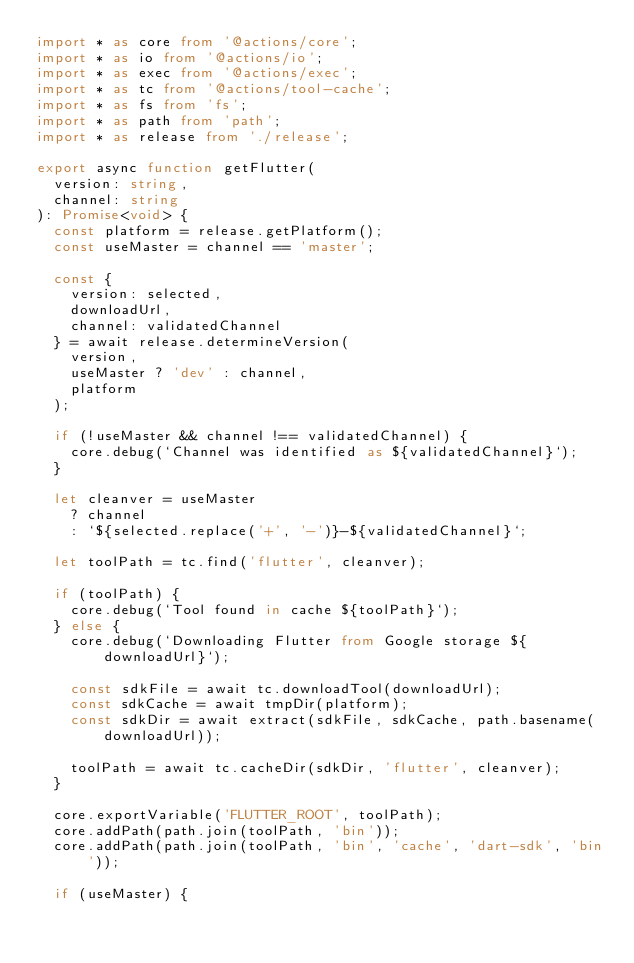Convert code to text. <code><loc_0><loc_0><loc_500><loc_500><_TypeScript_>import * as core from '@actions/core';
import * as io from '@actions/io';
import * as exec from '@actions/exec';
import * as tc from '@actions/tool-cache';
import * as fs from 'fs';
import * as path from 'path';
import * as release from './release';

export async function getFlutter(
  version: string,
  channel: string
): Promise<void> {
  const platform = release.getPlatform();
  const useMaster = channel == 'master';

  const {
    version: selected,
    downloadUrl,
    channel: validatedChannel
  } = await release.determineVersion(
    version,
    useMaster ? 'dev' : channel,
    platform
  );

  if (!useMaster && channel !== validatedChannel) {
    core.debug(`Channel was identified as ${validatedChannel}`);
  }

  let cleanver = useMaster
    ? channel
    : `${selected.replace('+', '-')}-${validatedChannel}`;

  let toolPath = tc.find('flutter', cleanver);

  if (toolPath) {
    core.debug(`Tool found in cache ${toolPath}`);
  } else {
    core.debug(`Downloading Flutter from Google storage ${downloadUrl}`);

    const sdkFile = await tc.downloadTool(downloadUrl);
    const sdkCache = await tmpDir(platform);
    const sdkDir = await extract(sdkFile, sdkCache, path.basename(downloadUrl));

    toolPath = await tc.cacheDir(sdkDir, 'flutter', cleanver);
  }

  core.exportVariable('FLUTTER_ROOT', toolPath);
  core.addPath(path.join(toolPath, 'bin'));
  core.addPath(path.join(toolPath, 'bin', 'cache', 'dart-sdk', 'bin'));

  if (useMaster) {</code> 